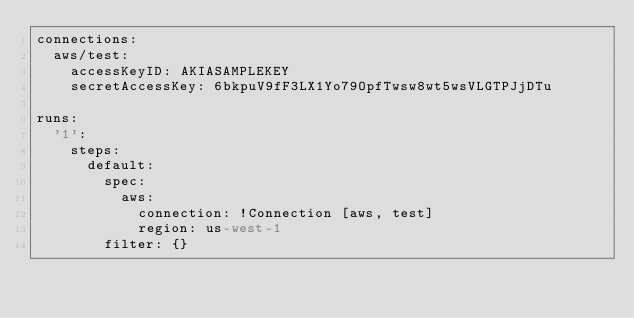Convert code to text. <code><loc_0><loc_0><loc_500><loc_500><_YAML_>connections:
  aws/test:
    accessKeyID: AKIASAMPLEKEY
    secretAccessKey: 6bkpuV9fF3LX1Yo79OpfTwsw8wt5wsVLGTPJjDTu

runs:
  '1':
    steps:
      default:
        spec:
          aws:
            connection: !Connection [aws, test]
            region: us-west-1
        filter: {}

</code> 